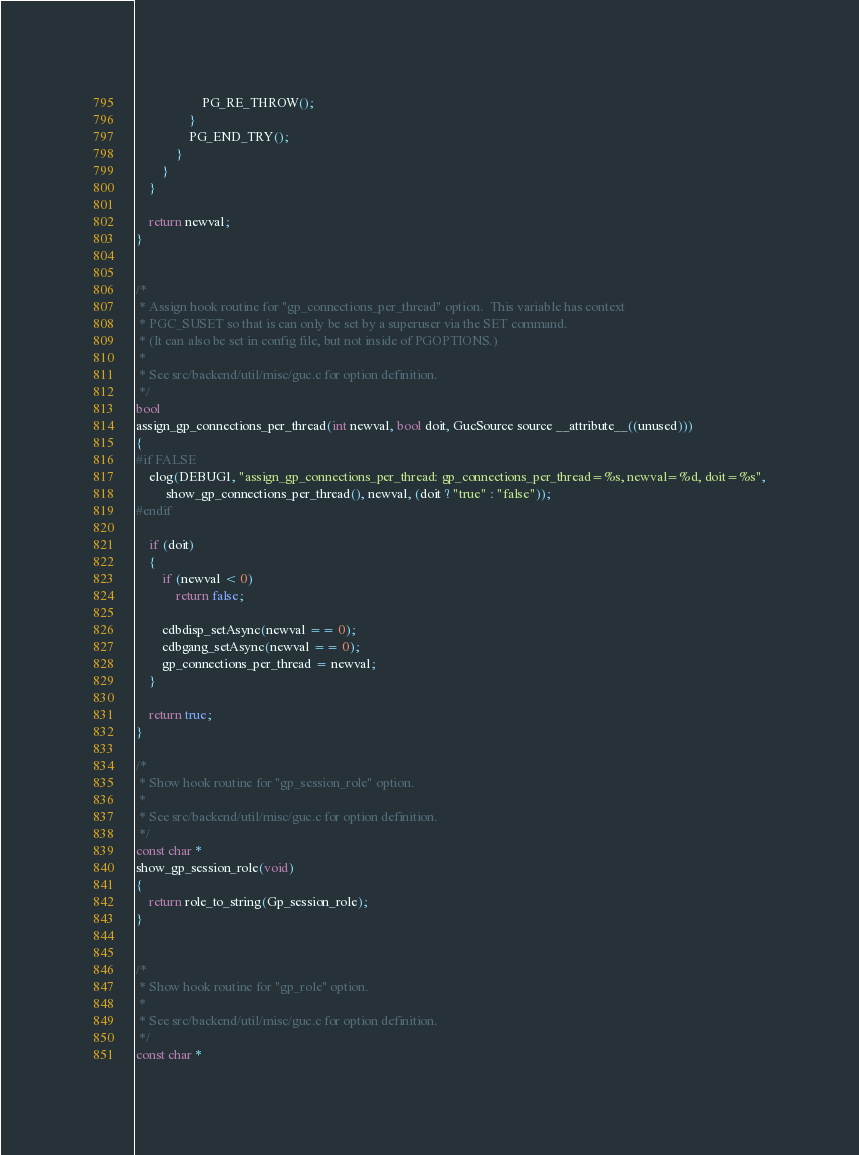<code> <loc_0><loc_0><loc_500><loc_500><_C_>					PG_RE_THROW();
				}
				PG_END_TRY();
			}
		}
	}

	return newval;
}


/*
 * Assign hook routine for "gp_connections_per_thread" option.  This variable has context
 * PGC_SUSET so that is can only be set by a superuser via the SET command.
 * (It can also be set in config file, but not inside of PGOPTIONS.)
 *
 * See src/backend/util/misc/guc.c for option definition.
 */
bool
assign_gp_connections_per_thread(int newval, bool doit, GucSource source __attribute__((unused)))
{
#if FALSE
	elog(DEBUG1, "assign_gp_connections_per_thread: gp_connections_per_thread=%s, newval=%d, doit=%s",
		 show_gp_connections_per_thread(), newval, (doit ? "true" : "false"));
#endif

	if (doit)
	{
		if (newval < 0)
			return false;

		cdbdisp_setAsync(newval == 0);
		cdbgang_setAsync(newval == 0);
		gp_connections_per_thread = newval;
	}

	return true;
}

/*
 * Show hook routine for "gp_session_role" option.
 *
 * See src/backend/util/misc/guc.c for option definition.
 */
const char *
show_gp_session_role(void)
{
	return role_to_string(Gp_session_role);
}


/*
 * Show hook routine for "gp_role" option.
 *
 * See src/backend/util/misc/guc.c for option definition.
 */
const char *</code> 